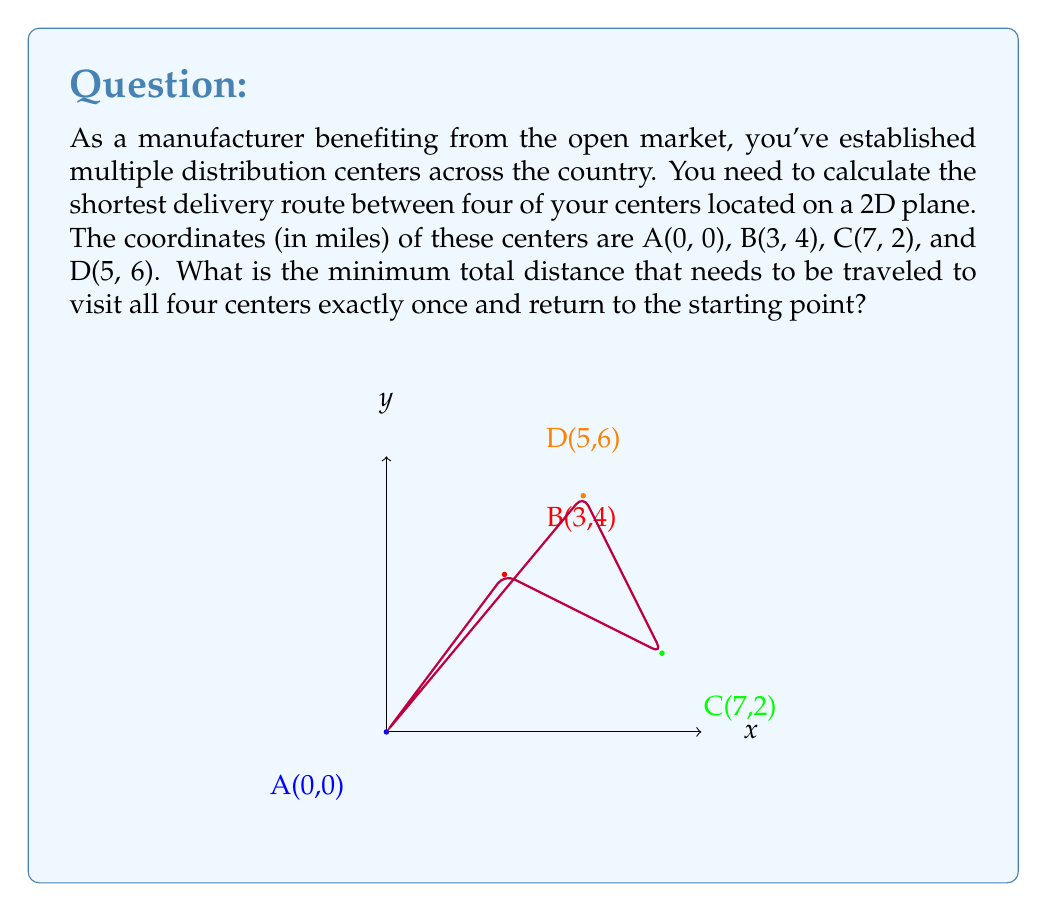Can you answer this question? To solve this problem, we need to calculate the distances between all pairs of points and find the shortest route. This is known as the Traveling Salesman Problem.

Step 1: Calculate distances between all pairs of points using the distance formula:
$$d = \sqrt{(x_2-x_1)^2 + (y_2-y_1)^2}$$

AB = $\sqrt{(3-0)^2 + (4-0)^2} = 5$
AC = $\sqrt{(7-0)^2 + (2-0)^2} = \sqrt{53}$
AD = $\sqrt{(5-0)^2 + (6-0)^2} = \sqrt{61}$
BC = $\sqrt{(7-3)^2 + (2-4)^2} = \sqrt{20}$
BD = $\sqrt{(5-3)^2 + (6-4)^2} = 2\sqrt{5}$
CD = $\sqrt{(5-7)^2 + (6-2)^2} = 2\sqrt{5}$

Step 2: Consider all possible routes:
ABCDA: $5 + \sqrt{20} + 2\sqrt{5} + \sqrt{61}$
ABDCA: $5 + 2\sqrt{5} + 2\sqrt{5} + \sqrt{53}$
ACBDA: $\sqrt{53} + \sqrt{20} + 2\sqrt{5} + 5$
ACDBA: $\sqrt{53} + 2\sqrt{5} + 2\sqrt{5} + 5$
ADBCA: $\sqrt{61} + 2\sqrt{5} + \sqrt{20} + 5$
ADCBA: $\sqrt{61} + 2\sqrt{5} + \sqrt{20} + 5$

Step 3: Compare the total distances:
ABCDA ≈ 22.07
ABDCA ≈ 22.29
ACBDA ≈ 22.07
ACDBA ≈ 22.29
ADBCA ≈ 22.07
ADCBA ≈ 22.07

The shortest routes are ABCDA, ACBDA, ADBCA, and ADCBA, all with the same minimum distance.
Answer: $5 + \sqrt{20} + 2\sqrt{5} + \sqrt{61}$ miles (≈ 22.07 miles) 